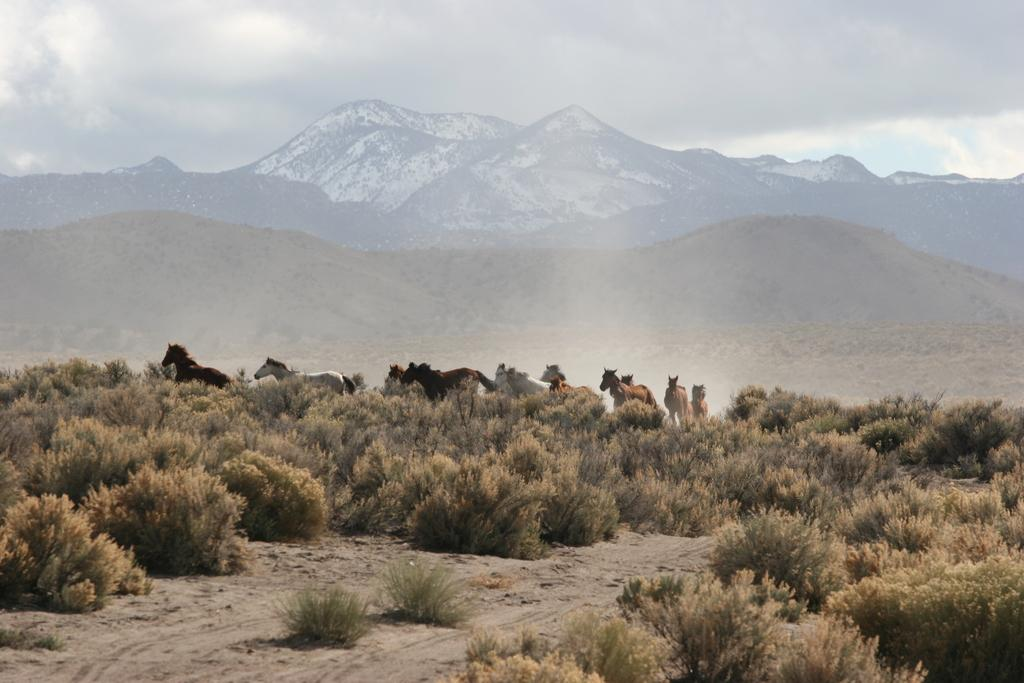What animals are in the center of the image? There are horses in the center of the image. What type of vegetation is present in the image? There are plants in the image. What geographical feature can be seen in the background of the image? There are mountains in the background of the image. What is visible at the top of the image? The sky is visible at the top of the image. Can you hear the horses laugh in the image? There is no sound in the image, and therefore it is not possible to hear the horses laugh. 